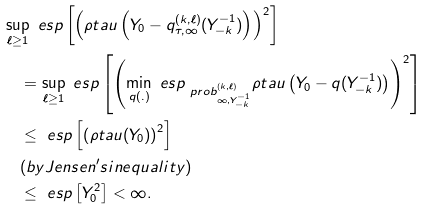<formula> <loc_0><loc_0><loc_500><loc_500>& \sup _ { \ell \geq 1 } { \ e s p \left [ \left ( \rho t a u \left ( Y _ { 0 } - q _ { \tau , \infty } ^ { ( k , \ell ) } ( Y _ { - k } ^ { - 1 } ) \right ) \right ) ^ { 2 } \right ] } \\ & \quad = \sup _ { \ell \geq 1 } { \ e s p \left [ \left ( \min _ { q ( . ) } \ e s p _ { \ p r o b ^ { ( k , \ell ) } _ { \infty , Y _ { - k } ^ { - 1 } } } \rho t a u \left ( Y _ { 0 } - q ( Y _ { - k } ^ { - 1 } ) \right ) \right ) ^ { 2 } \right ] } \\ & \quad \leq \ e s p \left [ \left ( \rho t a u ( Y _ { 0 } ) \right ) ^ { 2 } \right ] \\ & \quad ( b y J e n s e n ^ { \prime } s i n e q u a l i t y ) \\ & \quad \leq \ e s p \left [ Y _ { 0 } ^ { 2 } \right ] < \infty .</formula> 